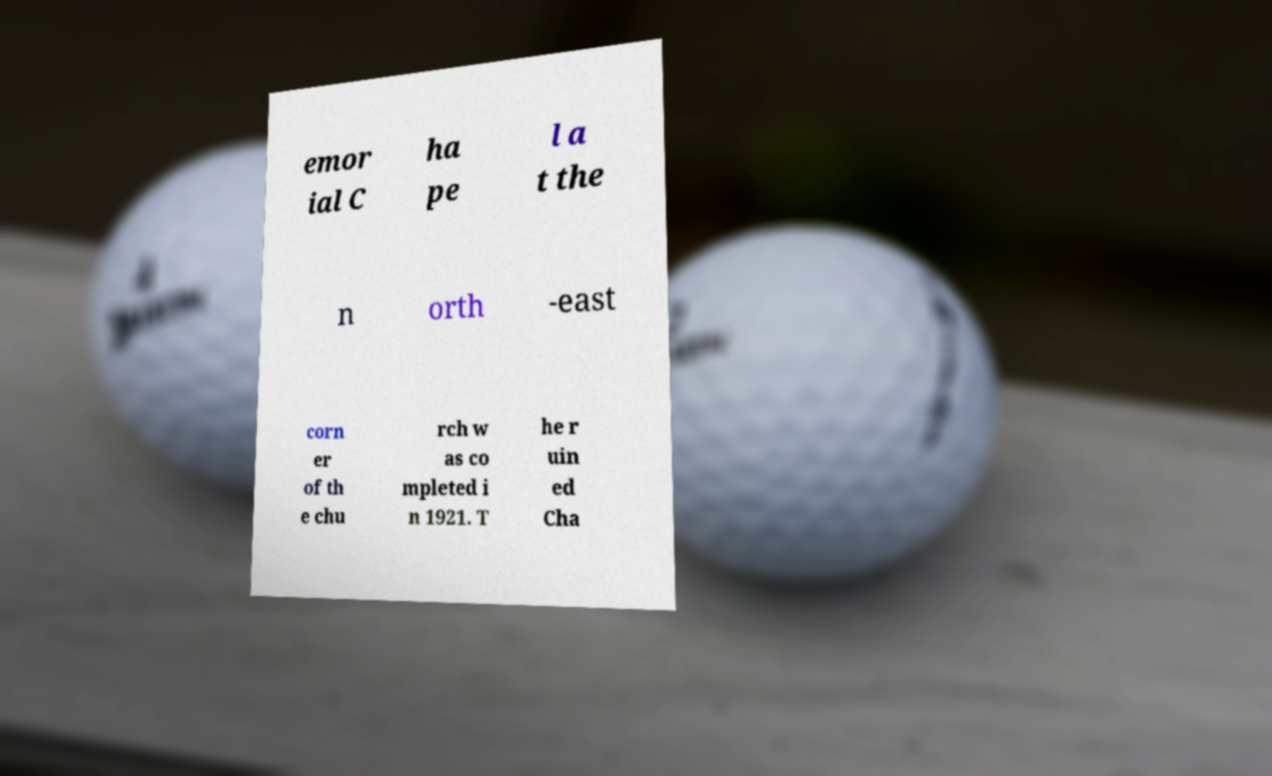Could you assist in decoding the text presented in this image and type it out clearly? emor ial C ha pe l a t the n orth -east corn er of th e chu rch w as co mpleted i n 1921. T he r uin ed Cha 